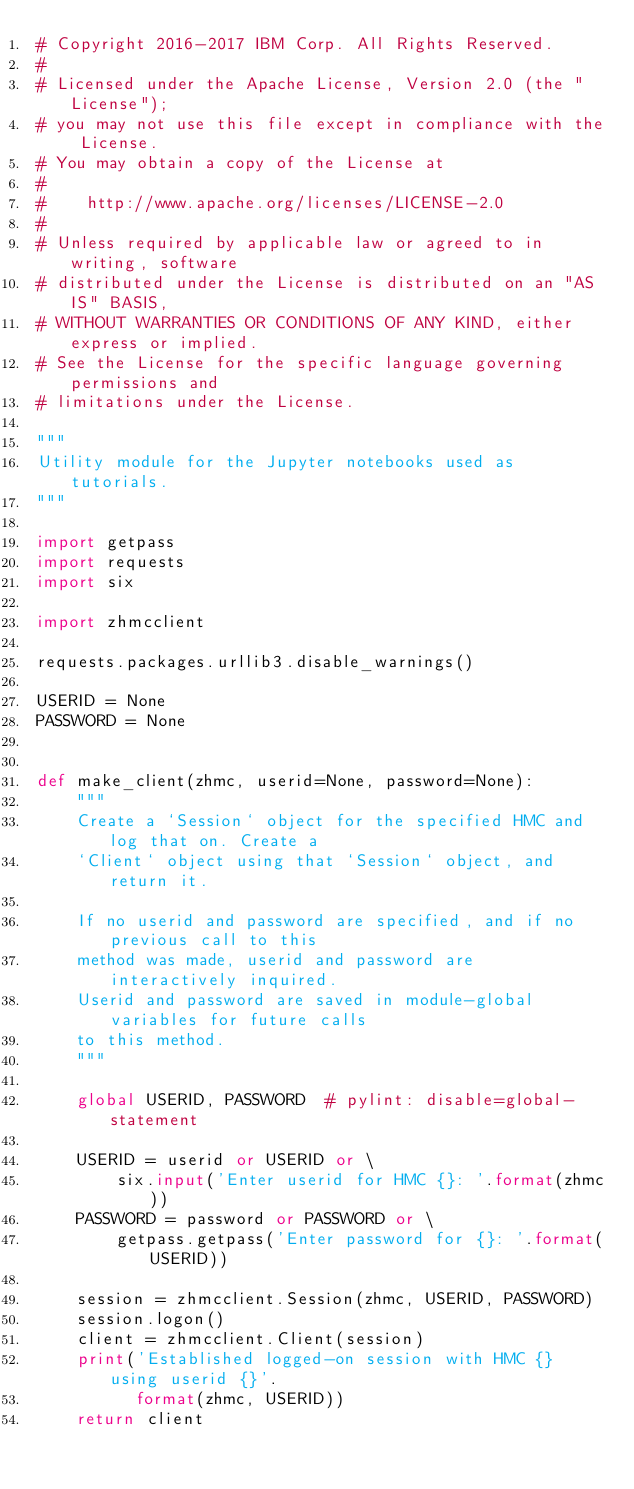<code> <loc_0><loc_0><loc_500><loc_500><_Python_># Copyright 2016-2017 IBM Corp. All Rights Reserved.
#
# Licensed under the Apache License, Version 2.0 (the "License");
# you may not use this file except in compliance with the License.
# You may obtain a copy of the License at
#
#    http://www.apache.org/licenses/LICENSE-2.0
#
# Unless required by applicable law or agreed to in writing, software
# distributed under the License is distributed on an "AS IS" BASIS,
# WITHOUT WARRANTIES OR CONDITIONS OF ANY KIND, either express or implied.
# See the License for the specific language governing permissions and
# limitations under the License.

"""
Utility module for the Jupyter notebooks used as tutorials.
"""

import getpass
import requests
import six

import zhmcclient

requests.packages.urllib3.disable_warnings()

USERID = None
PASSWORD = None


def make_client(zhmc, userid=None, password=None):
    """
    Create a `Session` object for the specified HMC and log that on. Create a
    `Client` object using that `Session` object, and return it.

    If no userid and password are specified, and if no previous call to this
    method was made, userid and password are interactively inquired.
    Userid and password are saved in module-global variables for future calls
    to this method.
    """

    global USERID, PASSWORD  # pylint: disable=global-statement

    USERID = userid or USERID or \
        six.input('Enter userid for HMC {}: '.format(zhmc))
    PASSWORD = password or PASSWORD or \
        getpass.getpass('Enter password for {}: '.format(USERID))

    session = zhmcclient.Session(zhmc, USERID, PASSWORD)
    session.logon()
    client = zhmcclient.Client(session)
    print('Established logged-on session with HMC {} using userid {}'.
          format(zhmc, USERID))
    return client
</code> 